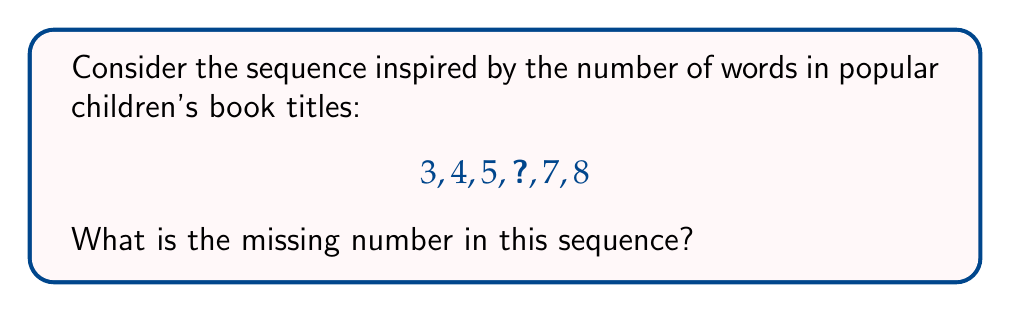Give your solution to this math problem. Let's approach this step-by-step:

1) First, we need to recognize the pattern in the sequence. 
   We can see that each number is increasing by 1.

2) Let's write out the differences between each consecutive number:
   $$3 \to 4 \: (+1)$$
   $$4 \to 5 \: (+1)$$
   $$5 \to ? \: (+1)$$
   $$? \to 7 \: (+1)$$
   $$7 \to 8 \: (+1)$$

3) We can see that the pattern is consistent: each number is 1 more than the previous number.

4) Therefore, the missing number should be 1 more than 5 and 1 less than 7.

5) We can calculate this as:
   $$5 + 1 = 6$$ or $$7 - 1 = 6$$

6) This sequence could represent the number of words in book titles like:
   "The Cat in the Hat" (4 words)
   "Green Eggs and Ham" (4 words)
   "Oh, the Places You'll Go!" (5 words)
   "The Very Hungry Caterpillar" (4 words)

   The missing number, 6, could represent a title like "Charlie and the Chocolate Factory".
Answer: 6 